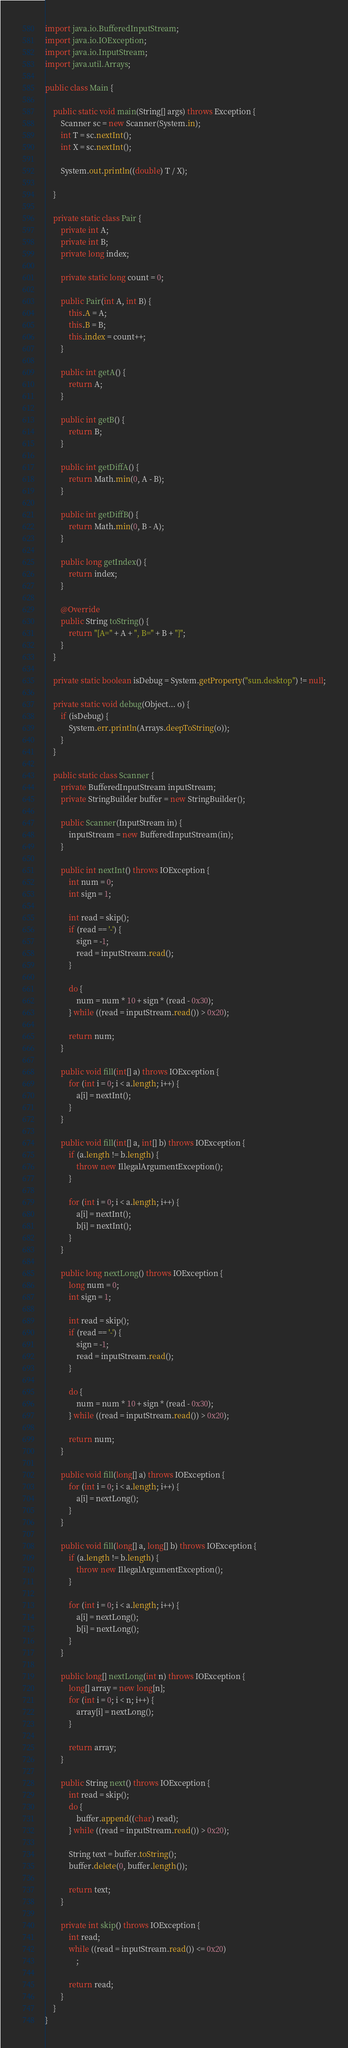<code> <loc_0><loc_0><loc_500><loc_500><_Java_>import java.io.BufferedInputStream;
import java.io.IOException;
import java.io.InputStream;
import java.util.Arrays;

public class Main {

	public static void main(String[] args) throws Exception {
		Scanner sc = new Scanner(System.in);
		int T = sc.nextInt();
		int X = sc.nextInt();

		System.out.println((double) T / X);

	}

	private static class Pair {
		private int A;
		private int B;
		private long index;

		private static long count = 0;

		public Pair(int A, int B) {
			this.A = A;
			this.B = B;
			this.index = count++;
		}

		public int getA() {
			return A;
		}

		public int getB() {
			return B;
		}

		public int getDiffA() {
			return Math.min(0, A - B);
		}

		public int getDiffB() {
			return Math.min(0, B - A);
		}

		public long getIndex() {
			return index;
		}

		@Override
		public String toString() {
			return "[A=" + A + ", B=" + B + "]";
		}
	}

	private static boolean isDebug = System.getProperty("sun.desktop") != null;

	private static void debug(Object... o) {
		if (isDebug) {
			System.err.println(Arrays.deepToString(o));
		}
	}

	public static class Scanner {
		private BufferedInputStream inputStream;
		private StringBuilder buffer = new StringBuilder();

		public Scanner(InputStream in) {
			inputStream = new BufferedInputStream(in);
		}

		public int nextInt() throws IOException {
			int num = 0;
			int sign = 1;

			int read = skip();
			if (read == '-') {
				sign = -1;
				read = inputStream.read();
			}

			do {
				num = num * 10 + sign * (read - 0x30);
			} while ((read = inputStream.read()) > 0x20);

			return num;
		}

		public void fill(int[] a) throws IOException {
			for (int i = 0; i < a.length; i++) {
				a[i] = nextInt();
			}
		}

		public void fill(int[] a, int[] b) throws IOException {
			if (a.length != b.length) {
				throw new IllegalArgumentException();
			}

			for (int i = 0; i < a.length; i++) {
				a[i] = nextInt();
				b[i] = nextInt();
			}
		}

		public long nextLong() throws IOException {
			long num = 0;
			int sign = 1;

			int read = skip();
			if (read == '-') {
				sign = -1;
				read = inputStream.read();
			}

			do {
				num = num * 10 + sign * (read - 0x30);
			} while ((read = inputStream.read()) > 0x20);

			return num;
		}

		public void fill(long[] a) throws IOException {
			for (int i = 0; i < a.length; i++) {
				a[i] = nextLong();
			}
		}

		public void fill(long[] a, long[] b) throws IOException {
			if (a.length != b.length) {
				throw new IllegalArgumentException();
			}

			for (int i = 0; i < a.length; i++) {
				a[i] = nextLong();
				b[i] = nextLong();
			}
		}

		public long[] nextLong(int n) throws IOException {
			long[] array = new long[n];
			for (int i = 0; i < n; i++) {
				array[i] = nextLong();
			}

			return array;
		}

		public String next() throws IOException {
			int read = skip();
			do {
				buffer.append((char) read);
			} while ((read = inputStream.read()) > 0x20);

			String text = buffer.toString();
			buffer.delete(0, buffer.length());

			return text;
		}

		private int skip() throws IOException {
			int read;
			while ((read = inputStream.read()) <= 0x20)
				;

			return read;
		}
	}
}
</code> 